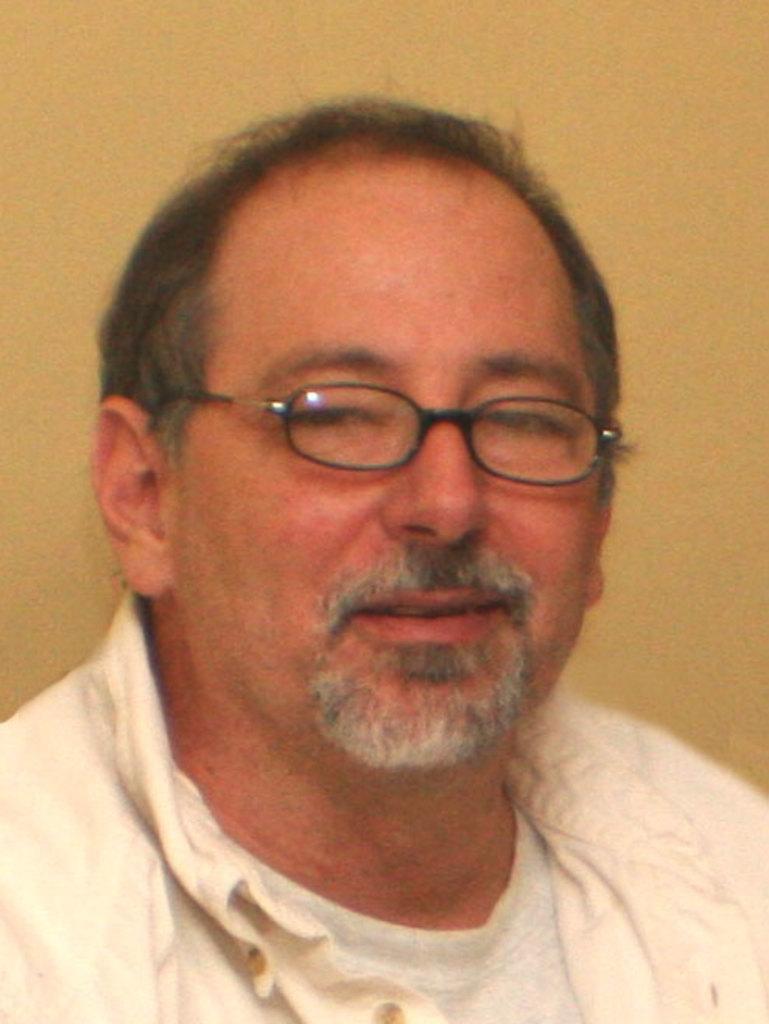Please provide a concise description of this image. In this picture we can see man who is laughing wore specs and a shirt. 